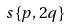Convert formula to latex. <formula><loc_0><loc_0><loc_500><loc_500>s \{ p , 2 q \}</formula> 